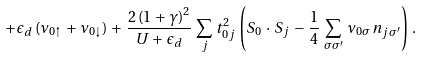<formula> <loc_0><loc_0><loc_500><loc_500>+ \, \epsilon _ { d } \, ( \nu _ { 0 \uparrow } \, + \, \nu _ { 0 \downarrow } ) \, + \, \frac { 2 \, ( 1 \, + \, \gamma ) ^ { 2 } } { U \, + \, \epsilon _ { d } } \, \sum _ { j } \, t _ { 0 j } ^ { 2 } \, \left ( { S } _ { 0 } \, \cdot \, { S } _ { j } \, - \, \frac { 1 } { 4 } \, \sum _ { \sigma \sigma ^ { \prime } } \, \nu _ { 0 \sigma } \, n _ { j \sigma ^ { \prime } } \right ) \, .</formula> 